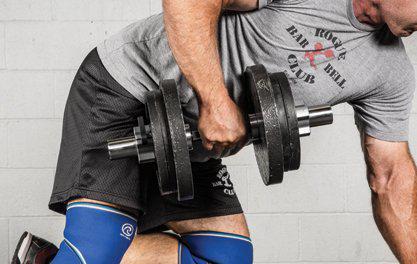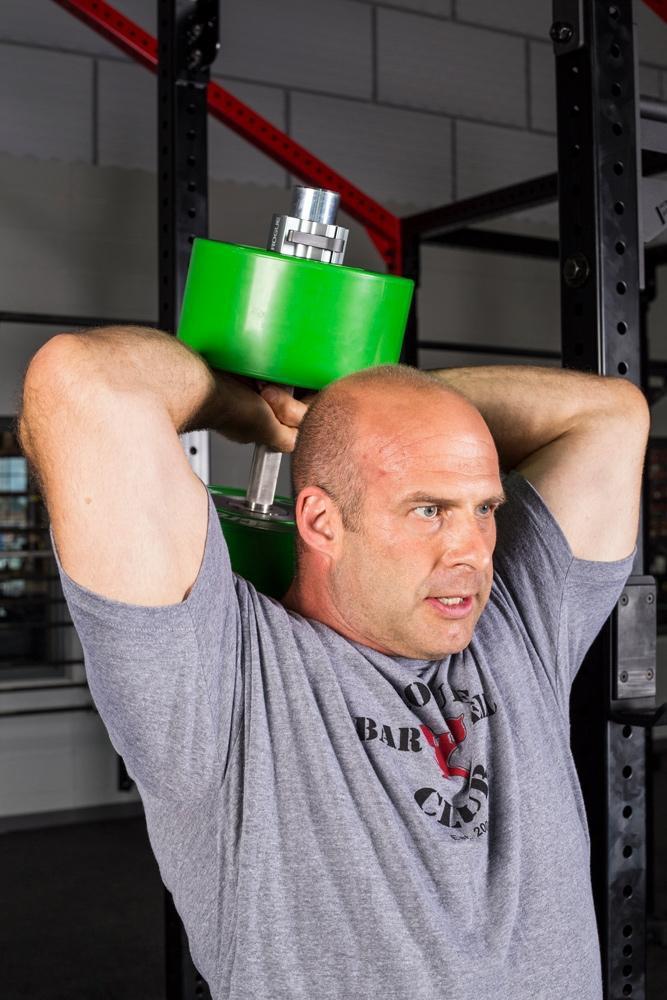The first image is the image on the left, the second image is the image on the right. Given the left and right images, does the statement "A weightlifter in one image has one arm stretched straight up, holding a weighted barbell." hold true? Answer yes or no. No. 